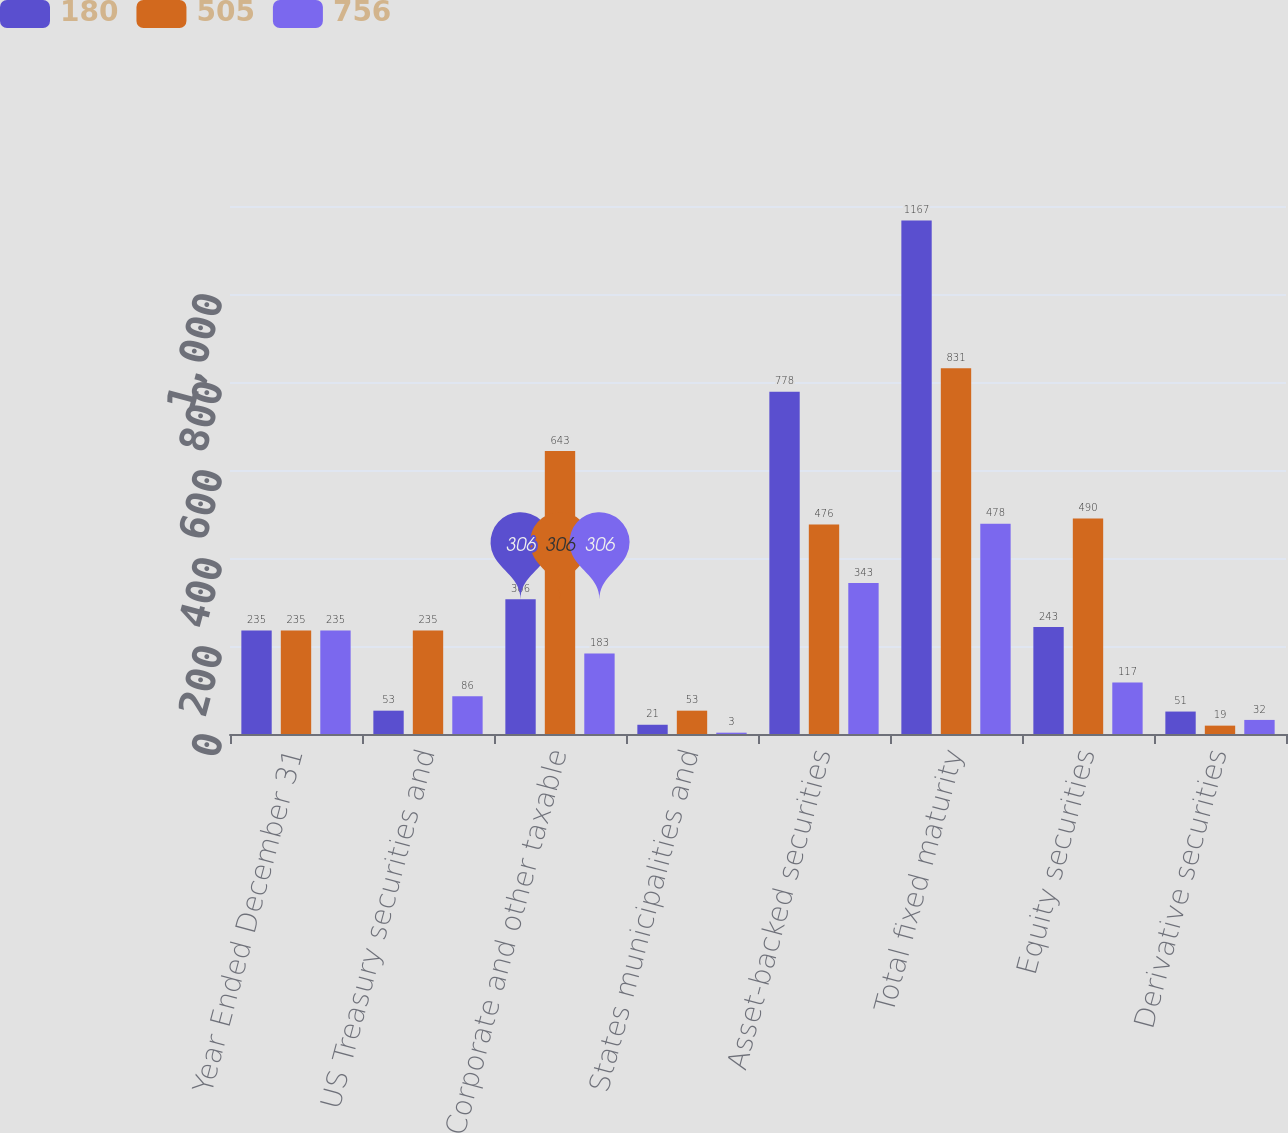Convert chart to OTSL. <chart><loc_0><loc_0><loc_500><loc_500><stacked_bar_chart><ecel><fcel>Year Ended December 31<fcel>US Treasury securities and<fcel>Corporate and other taxable<fcel>States municipalities and<fcel>Asset-backed securities<fcel>Total fixed maturity<fcel>Equity securities<fcel>Derivative securities<nl><fcel>180<fcel>235<fcel>53<fcel>306<fcel>21<fcel>778<fcel>1167<fcel>243<fcel>51<nl><fcel>505<fcel>235<fcel>235<fcel>643<fcel>53<fcel>476<fcel>831<fcel>490<fcel>19<nl><fcel>756<fcel>235<fcel>86<fcel>183<fcel>3<fcel>343<fcel>478<fcel>117<fcel>32<nl></chart> 